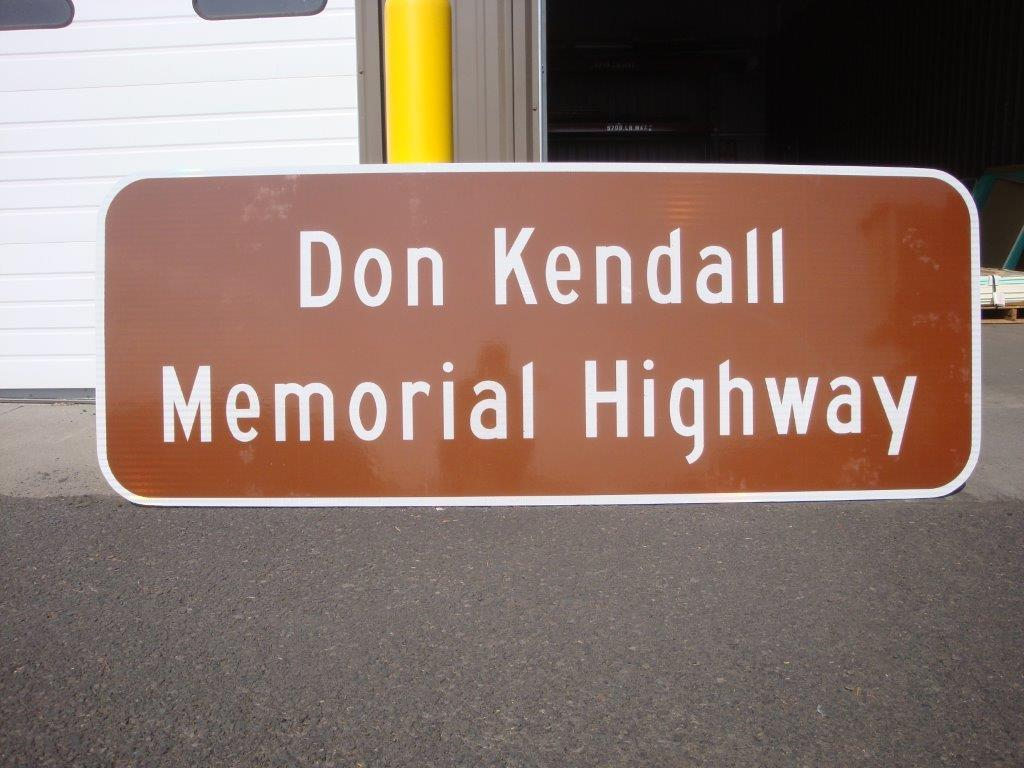<image>
Give a short and clear explanation of the subsequent image. the name Don Kendall is on the brown sign 